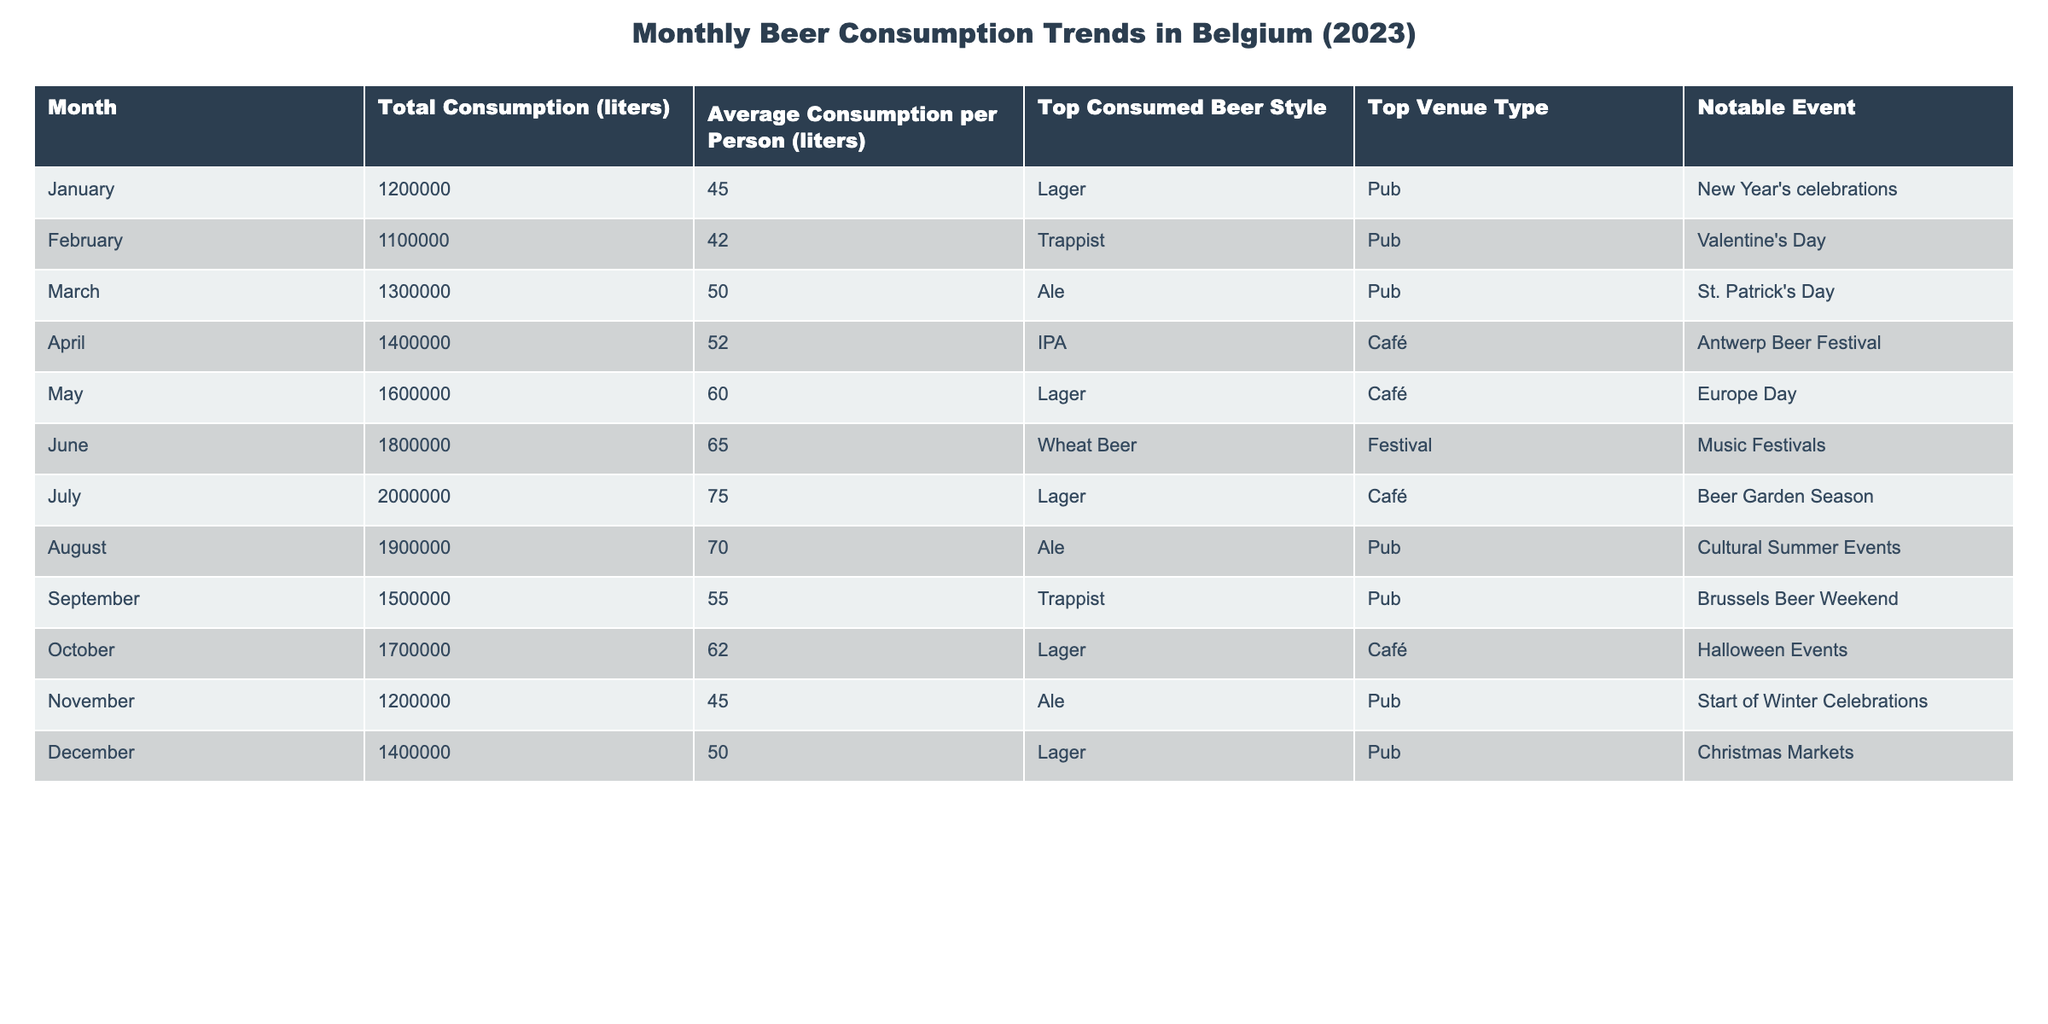What is the total beer consumption in Belgium for July? According to the table, the total beer consumption for July is presented under "Total Consumption (liters)", which states **2000000 liters**.
Answer: 2000000 liters Which month had the highest average beer consumption per person? By examining the "Average Consumption per Person (liters)" column, we find that **July** has the highest average at **75.0 liters**.
Answer: July What was the top consumed beer style in March? Looking at the "Top Consumed Beer Style" for March, it shows **Ale**.
Answer: Ale How much more beer was consumed in June compared to February? For June, the total consumption is **1800000 liters**, and for February, it is **1100000 liters**. The difference is calculated as 1800000 - 1100000 = **700000 liters**.
Answer: 700000 liters Was "Wheat Beer" consumed the most in any month? Checking the "Top Consumed Beer Style" across all months, **Wheat Beer** appears as the top consumed style only in June, confirming it was the most consumed beer style that month.
Answer: Yes What is the total consumption for the first half of the year (January to June)? We sum the total consumption from January (1200000), February (1100000), March (1300000), April (1400000), May (1600000), and June (1800000). The total is 1200000 + 1100000 + 1300000 + 1400000 + 1600000 + 1800000 = **9300000 liters**.
Answer: 9300000 liters In which month and venue type did "IPA" become the top consumed beer style? Referring to the table under "Top Consumed Beer Style" and "Top Venue Type", **IPA** is listed as the most consumed in **April** and the venue type is a **Café**.
Answer: April, Café What was the average beer consumption for the months of October and November? October's average is **62.0 liters** and November's is **45.0 liters**. The average of these two months is calculated as (62.0 + 45.0) / 2 = **53.5 liters**.
Answer: 53.5 liters Did the total beer consumption exceed 1.5 million liters in August? The total consumption for August is **1900000 liters**, which is indeed more than 1.5 million liters.
Answer: Yes Which month had a notable event related to Halloween? The table indicates that **October** had the notable event labeled as "Halloween Events".
Answer: October 